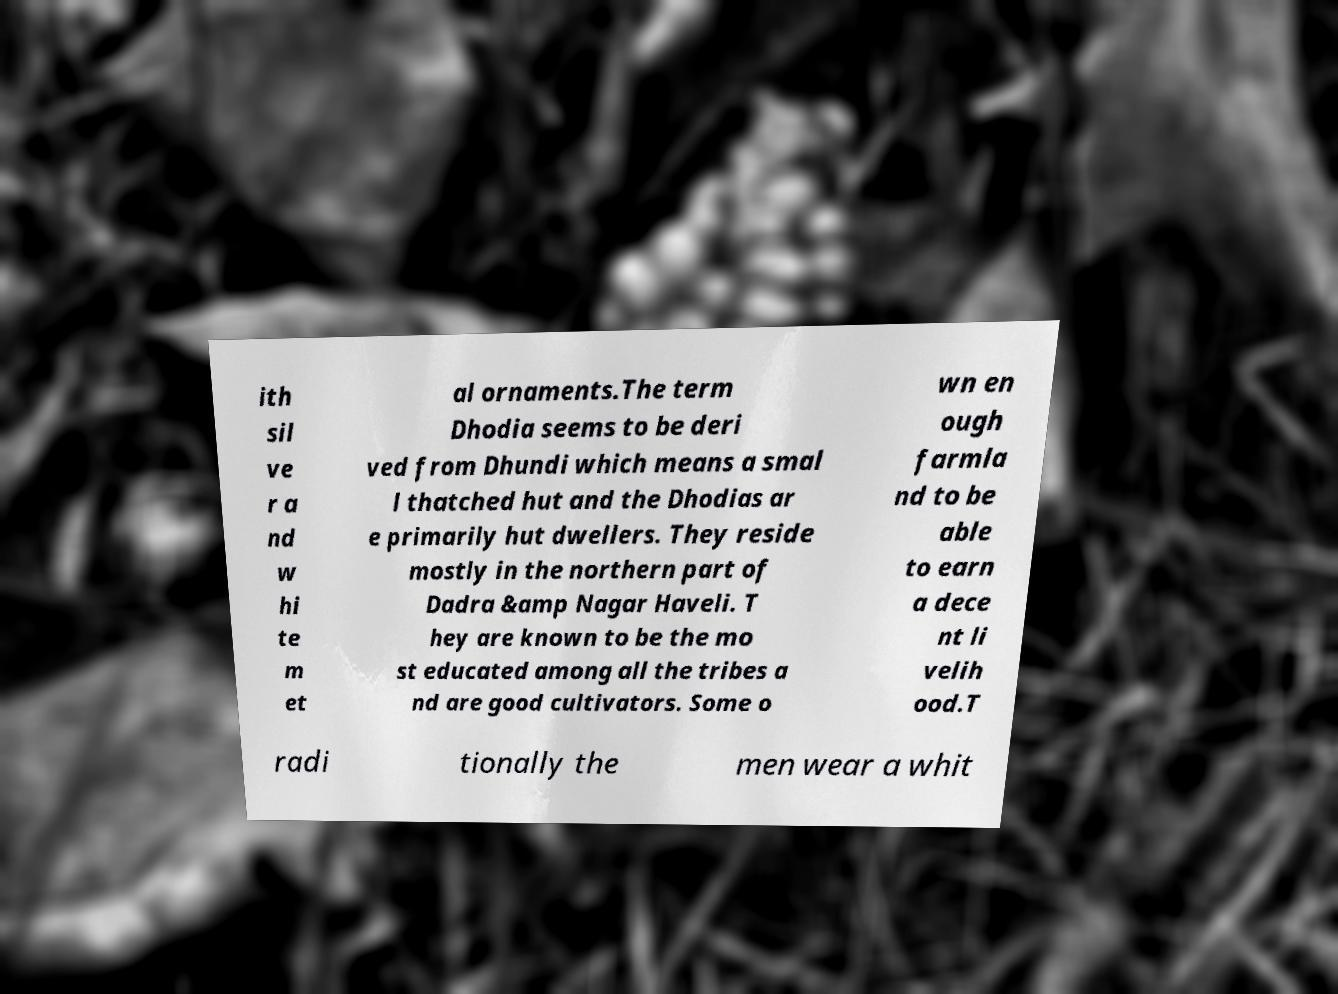Please read and relay the text visible in this image. What does it say? ith sil ve r a nd w hi te m et al ornaments.The term Dhodia seems to be deri ved from Dhundi which means a smal l thatched hut and the Dhodias ar e primarily hut dwellers. They reside mostly in the northern part of Dadra &amp Nagar Haveli. T hey are known to be the mo st educated among all the tribes a nd are good cultivators. Some o wn en ough farmla nd to be able to earn a dece nt li velih ood.T radi tionally the men wear a whit 